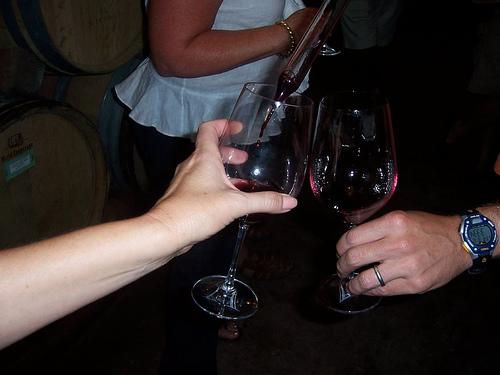What are the people holding?
Short answer required. Wine glasses. How many people are there?
Keep it brief. 3. What flavoring is being placed in the drinks?
Quick response, please. Cherry. 